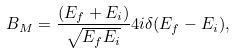<formula> <loc_0><loc_0><loc_500><loc_500>B _ { M } = \frac { ( E _ { f } + E _ { i } ) } { \sqrt { E _ { f } E _ { i } } } 4 i \delta ( E _ { f } - E _ { i } ) ,</formula> 